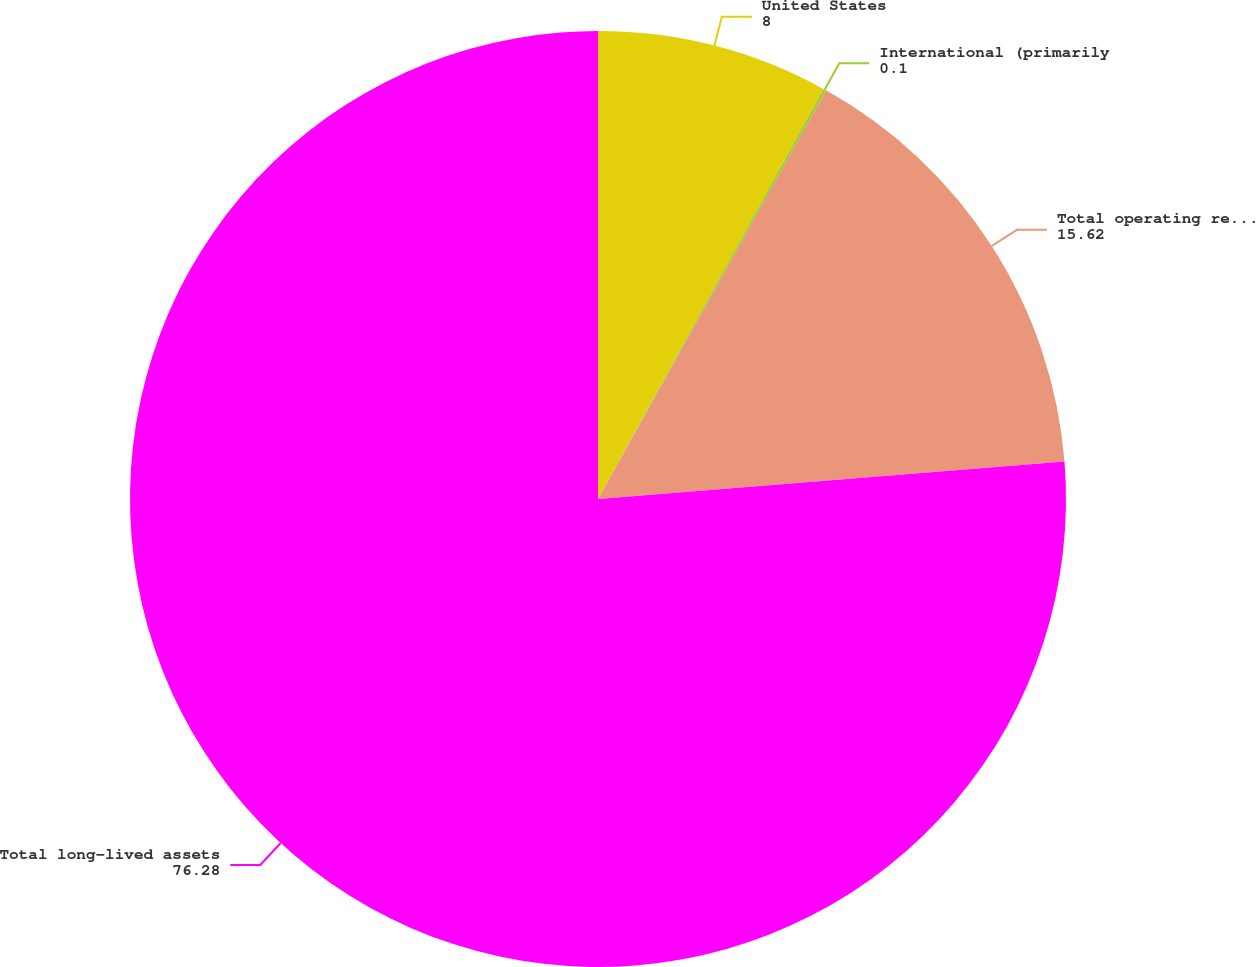Convert chart to OTSL. <chart><loc_0><loc_0><loc_500><loc_500><pie_chart><fcel>United States<fcel>International (primarily<fcel>Total operating revenues<fcel>Total long-lived assets<nl><fcel>8.0%<fcel>0.1%<fcel>15.62%<fcel>76.28%<nl></chart> 